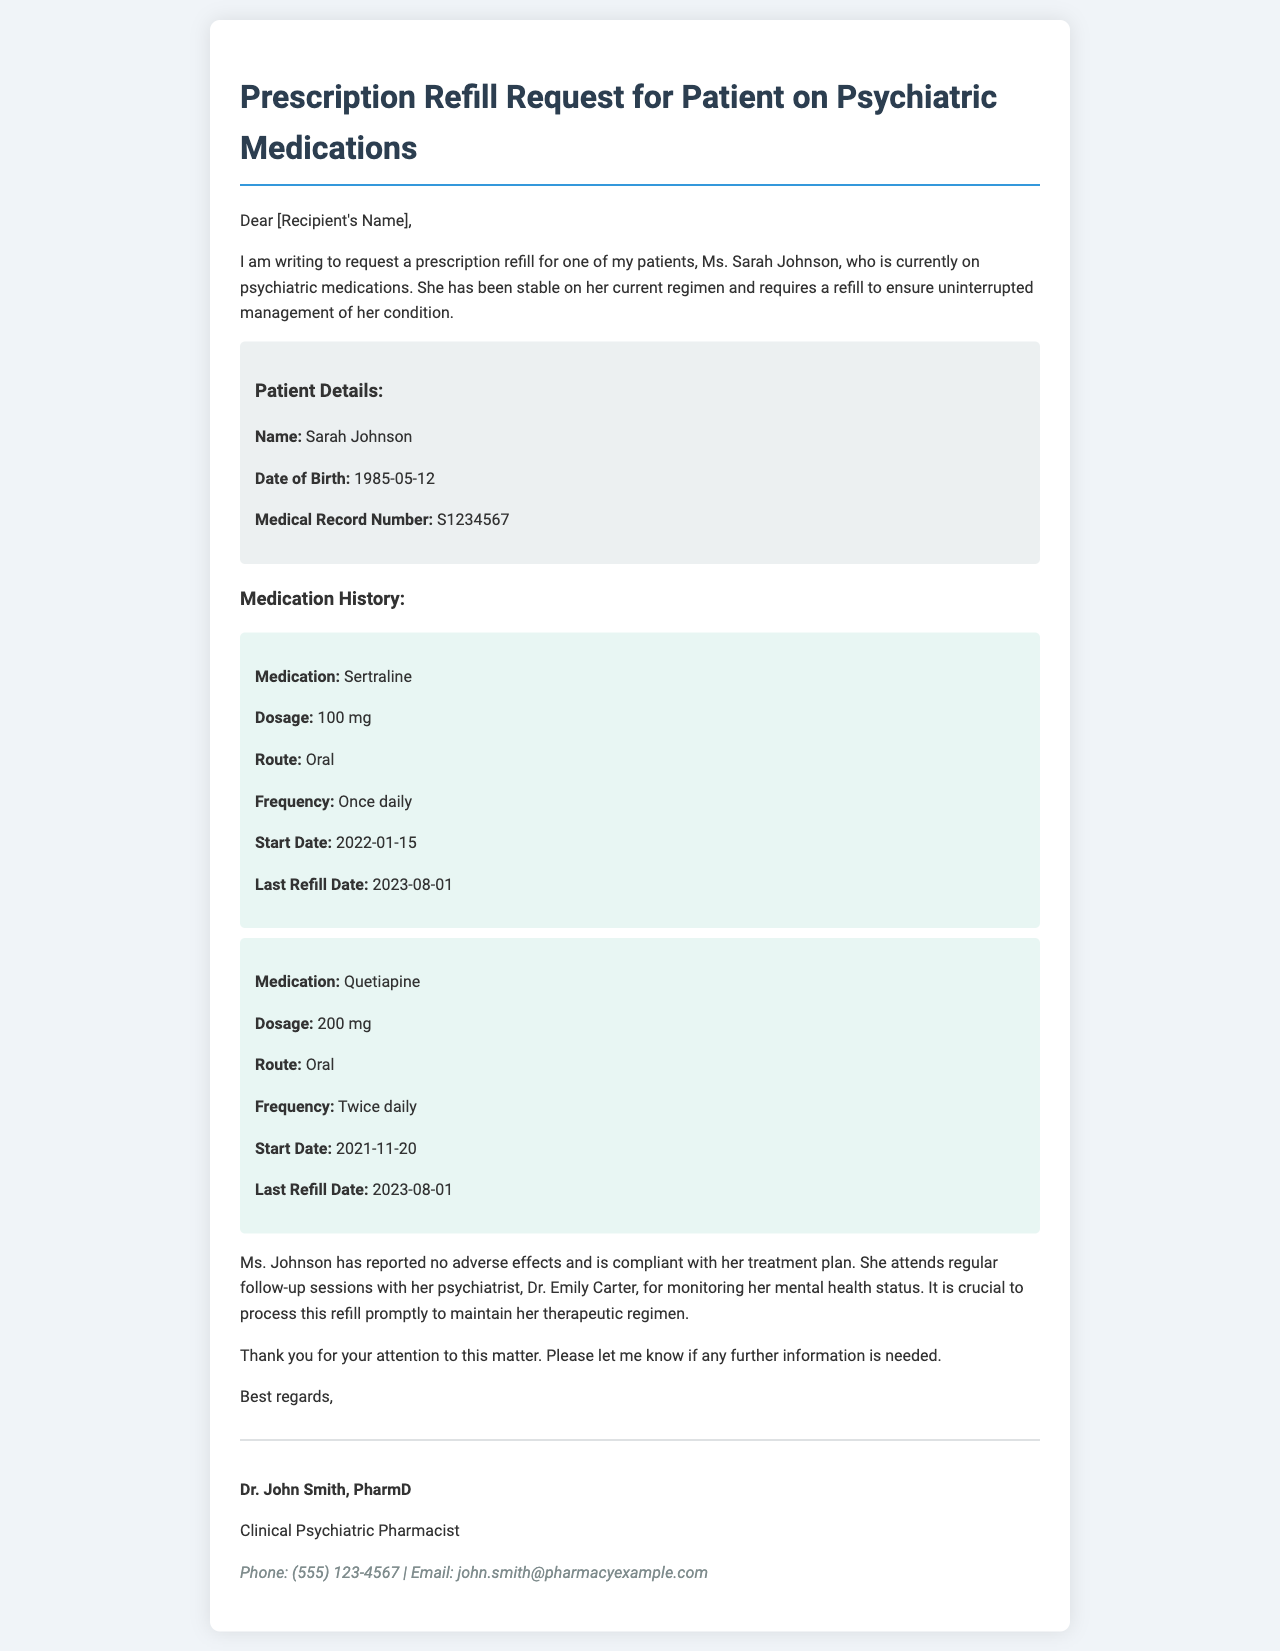What is the patient's name? The patient's name is specified in the document as Ms. Sarah Johnson.
Answer: Sarah Johnson What is the dosage of Sertraline? The dosage of Sertraline is mentioned in the medication history section of the document as 100 mg.
Answer: 100 mg Who is the patient's psychiatrist? The document states that the patient attends regular follow-up sessions with Dr. Emily Carter.
Answer: Dr. Emily Carter What is the frequency of Quetiapine? The frequency of Quetiapine is provided in the medication details, which states it is administered twice daily.
Answer: Twice daily When was the last refill date for both medications? The last refill date for both Sertraline and Quetiapine is given as August 1, 2023.
Answer: 2023-08-01 What is the primary concern addressed in the request? The request emphasizes the need for timely processing of the refill to maintain Ms. Johnson's therapeutic regimen.
Answer: Timely processing of the refill What is the role of Dr. John Smith? The document describes Dr. John Smith as a Clinical Psychiatric Pharmacist.
Answer: Clinical Psychiatric Pharmacist 